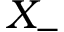<formula> <loc_0><loc_0><loc_500><loc_500>X _ { - }</formula> 